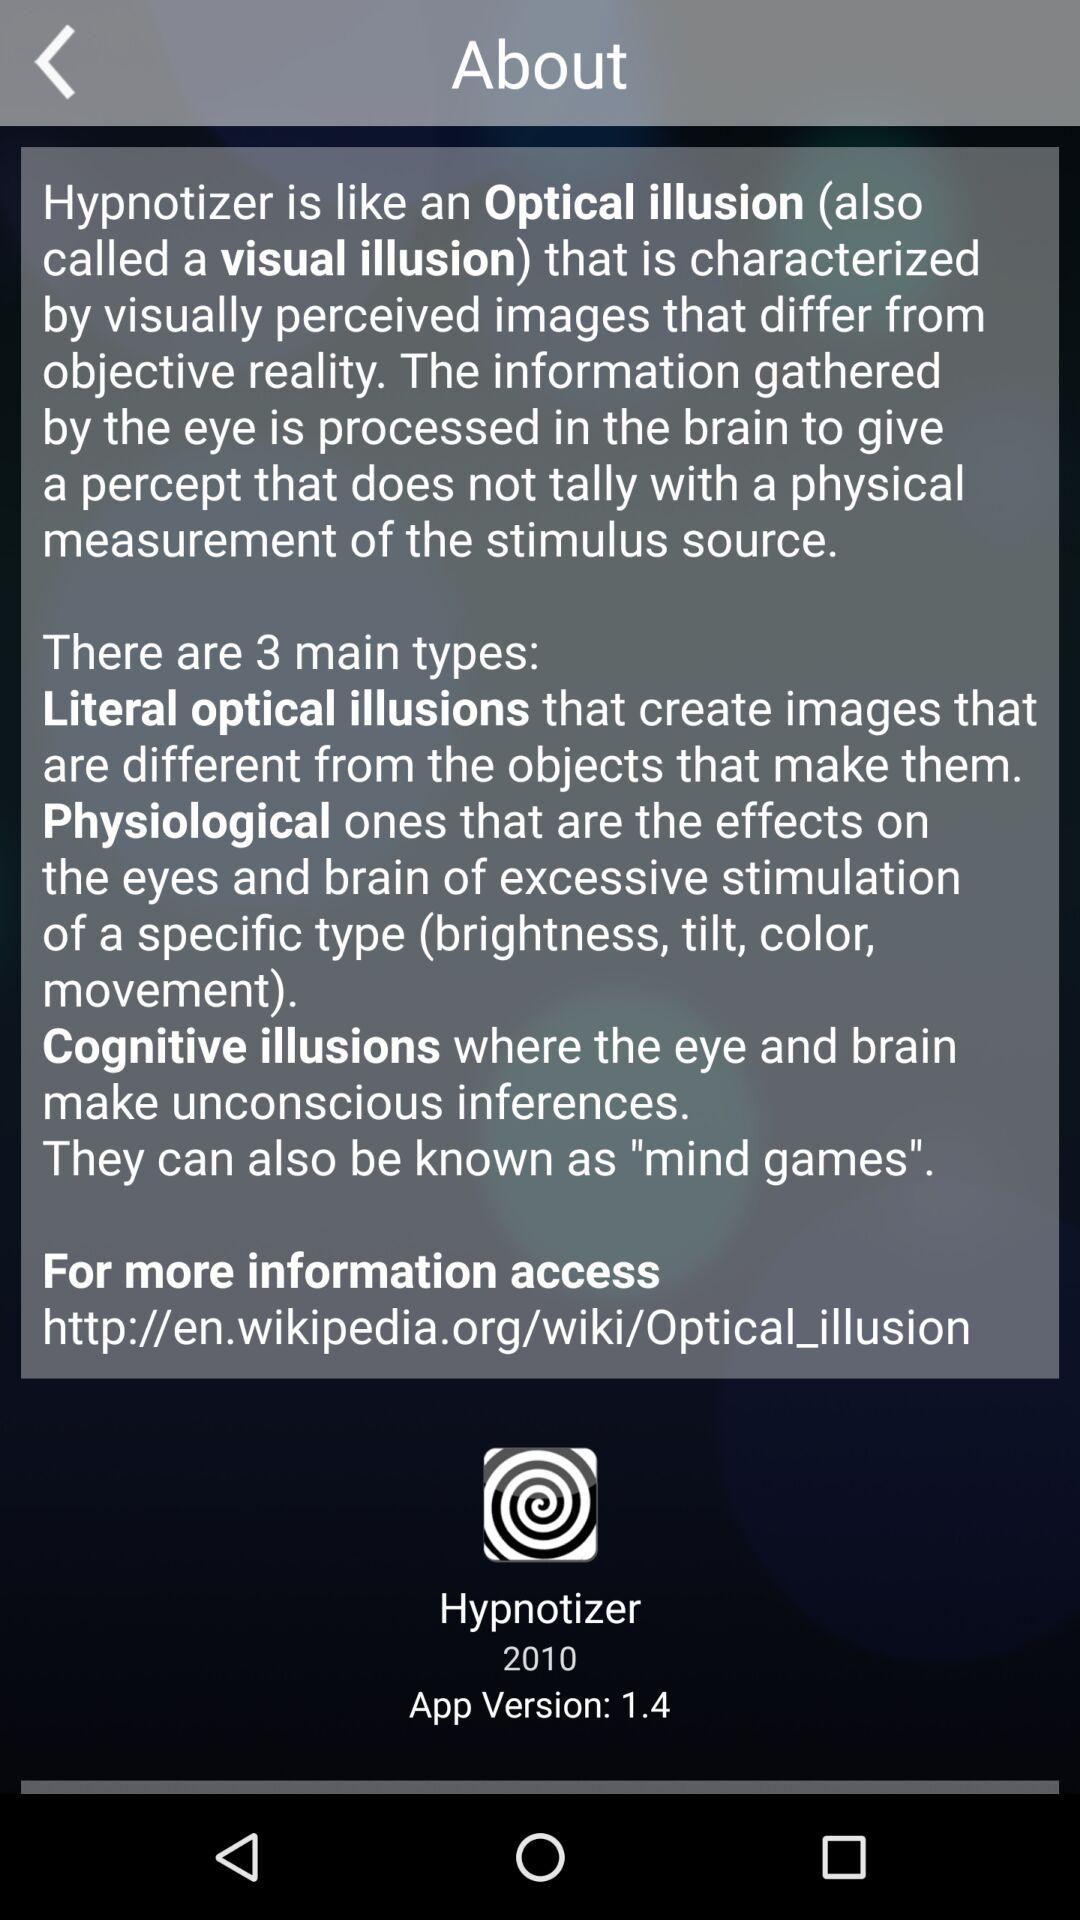What is the app version of "Hypnotizer"? The app version is 1.4. 